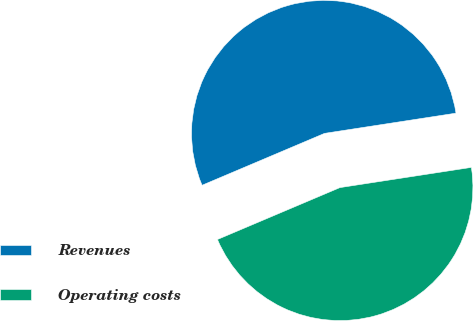Convert chart to OTSL. <chart><loc_0><loc_0><loc_500><loc_500><pie_chart><fcel>Revenues<fcel>Operating costs<nl><fcel>53.95%<fcel>46.05%<nl></chart> 